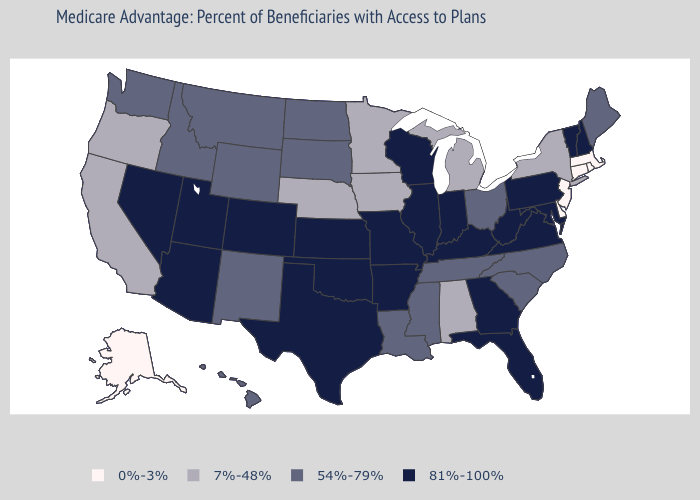Does Pennsylvania have the lowest value in the Northeast?
Be succinct. No. What is the lowest value in states that border Utah?
Concise answer only. 54%-79%. What is the value of Montana?
Write a very short answer. 54%-79%. Name the states that have a value in the range 7%-48%?
Give a very brief answer. Alabama, California, Iowa, Michigan, Minnesota, Nebraska, New York, Oregon. What is the value of Utah?
Give a very brief answer. 81%-100%. How many symbols are there in the legend?
Answer briefly. 4. Which states have the lowest value in the MidWest?
Quick response, please. Iowa, Michigan, Minnesota, Nebraska. How many symbols are there in the legend?
Short answer required. 4. Name the states that have a value in the range 81%-100%?
Answer briefly. Arkansas, Arizona, Colorado, Florida, Georgia, Illinois, Indiana, Kansas, Kentucky, Maryland, Missouri, New Hampshire, Nevada, Oklahoma, Pennsylvania, Texas, Utah, Virginia, Vermont, Wisconsin, West Virginia. What is the lowest value in states that border Nebraska?
Answer briefly. 7%-48%. What is the value of Texas?
Keep it brief. 81%-100%. Does Colorado have the highest value in the West?
Keep it brief. Yes. Does Wyoming have the same value as Idaho?
Quick response, please. Yes. What is the value of Illinois?
Answer briefly. 81%-100%. Does Colorado have the same value as Indiana?
Give a very brief answer. Yes. 